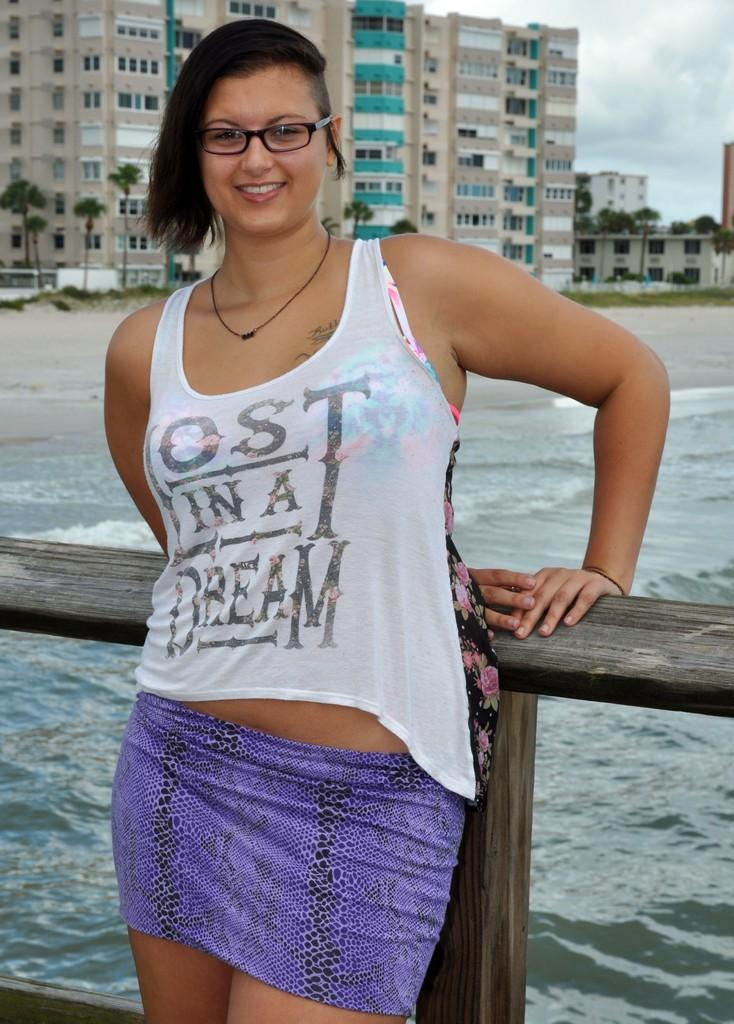What is the main subject of the image? There is a woman standing in the image. What can be seen in the background of the image? There is water, trees, and a building with windows visible in the image. What is the condition of the sky in the image? The sky is visible in the image and appears cloudy. What type of sweater is the woman wearing in the image? There is no sweater visible in the image; the woman is not wearing any clothing. What flavor of jam can be seen on the trees in the image? There is no jam present in the image; the trees are not related to any food items. 